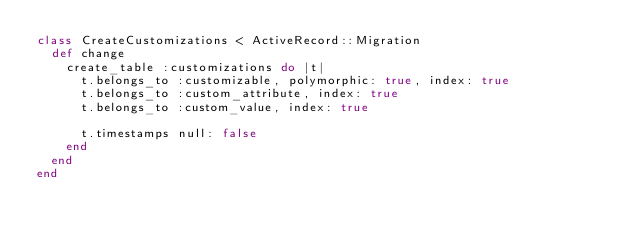Convert code to text. <code><loc_0><loc_0><loc_500><loc_500><_Ruby_>class CreateCustomizations < ActiveRecord::Migration
  def change
    create_table :customizations do |t|
      t.belongs_to :customizable, polymorphic: true, index: true
      t.belongs_to :custom_attribute, index: true
      t.belongs_to :custom_value, index: true

      t.timestamps null: false
    end
  end
end
</code> 